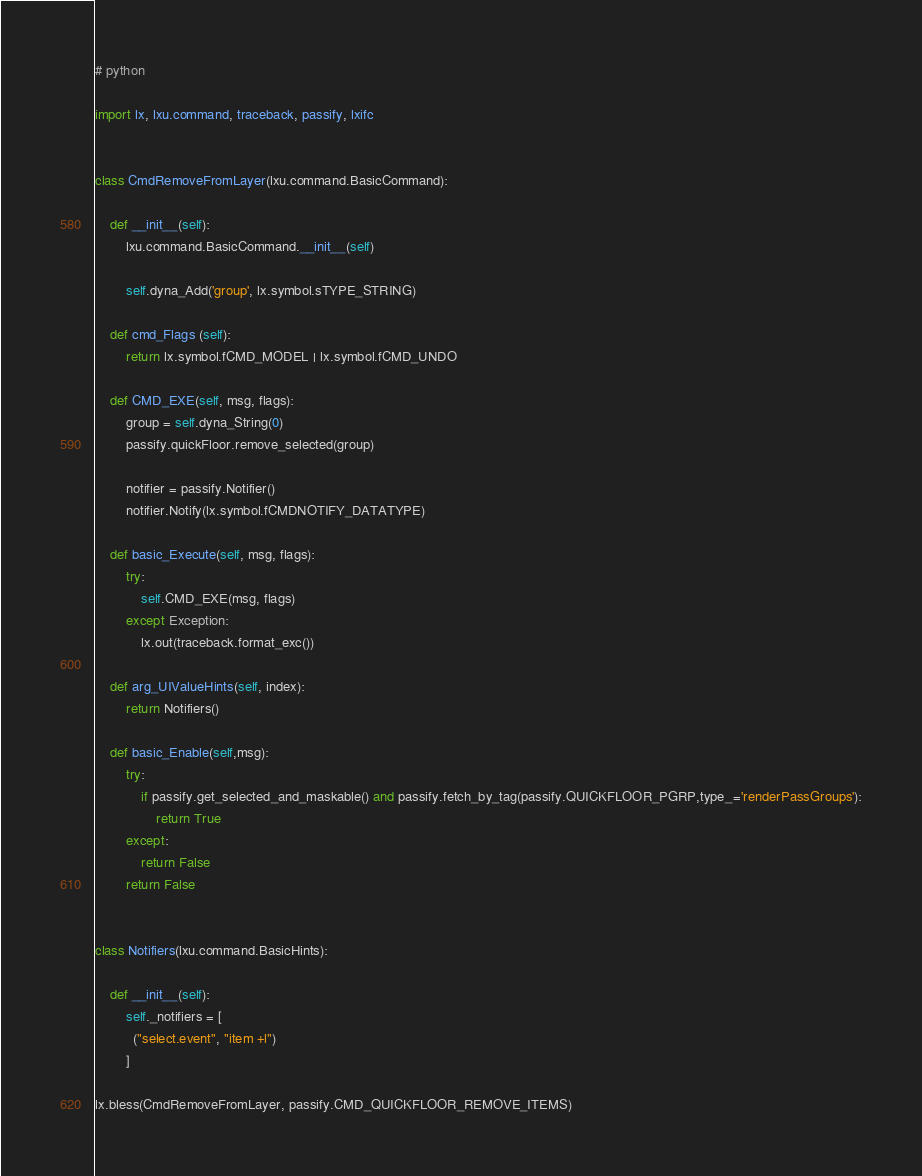Convert code to text. <code><loc_0><loc_0><loc_500><loc_500><_Python_># python

import lx, lxu.command, traceback, passify, lxifc


class CmdRemoveFromLayer(lxu.command.BasicCommand):

    def __init__(self):
        lxu.command.BasicCommand.__init__(self)

        self.dyna_Add('group', lx.symbol.sTYPE_STRING)

    def cmd_Flags (self):
        return lx.symbol.fCMD_MODEL | lx.symbol.fCMD_UNDO

    def CMD_EXE(self, msg, flags):
        group = self.dyna_String(0)
        passify.quickFloor.remove_selected(group)

        notifier = passify.Notifier()
        notifier.Notify(lx.symbol.fCMDNOTIFY_DATATYPE)

    def basic_Execute(self, msg, flags):
        try:
            self.CMD_EXE(msg, flags)
        except Exception:
            lx.out(traceback.format_exc())

    def arg_UIValueHints(self, index):
        return Notifiers()

    def basic_Enable(self,msg):
        try:
            if passify.get_selected_and_maskable() and passify.fetch_by_tag(passify.QUICKFLOOR_PGRP,type_='renderPassGroups'):
                return True
        except:
            return False
        return False


class Notifiers(lxu.command.BasicHints):

    def __init__(self):
        self._notifiers = [
          ("select.event", "item +l")
        ]

lx.bless(CmdRemoveFromLayer, passify.CMD_QUICKFLOOR_REMOVE_ITEMS)
</code> 